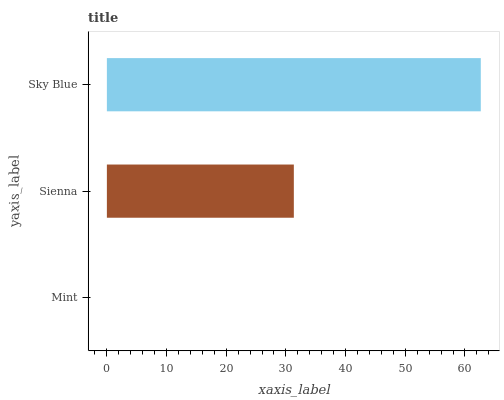Is Mint the minimum?
Answer yes or no. Yes. Is Sky Blue the maximum?
Answer yes or no. Yes. Is Sienna the minimum?
Answer yes or no. No. Is Sienna the maximum?
Answer yes or no. No. Is Sienna greater than Mint?
Answer yes or no. Yes. Is Mint less than Sienna?
Answer yes or no. Yes. Is Mint greater than Sienna?
Answer yes or no. No. Is Sienna less than Mint?
Answer yes or no. No. Is Sienna the high median?
Answer yes or no. Yes. Is Sienna the low median?
Answer yes or no. Yes. Is Mint the high median?
Answer yes or no. No. Is Sky Blue the low median?
Answer yes or no. No. 